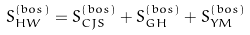<formula> <loc_0><loc_0><loc_500><loc_500>S ^ { \left ( { b o s } \right ) } _ { H W } = S ^ { \left ( { b o s } \right ) } _ { C J S } + S ^ { \left ( { b o s } \right ) } _ { G H } + S ^ { \left ( { b o s } \right ) } _ { Y M }</formula> 